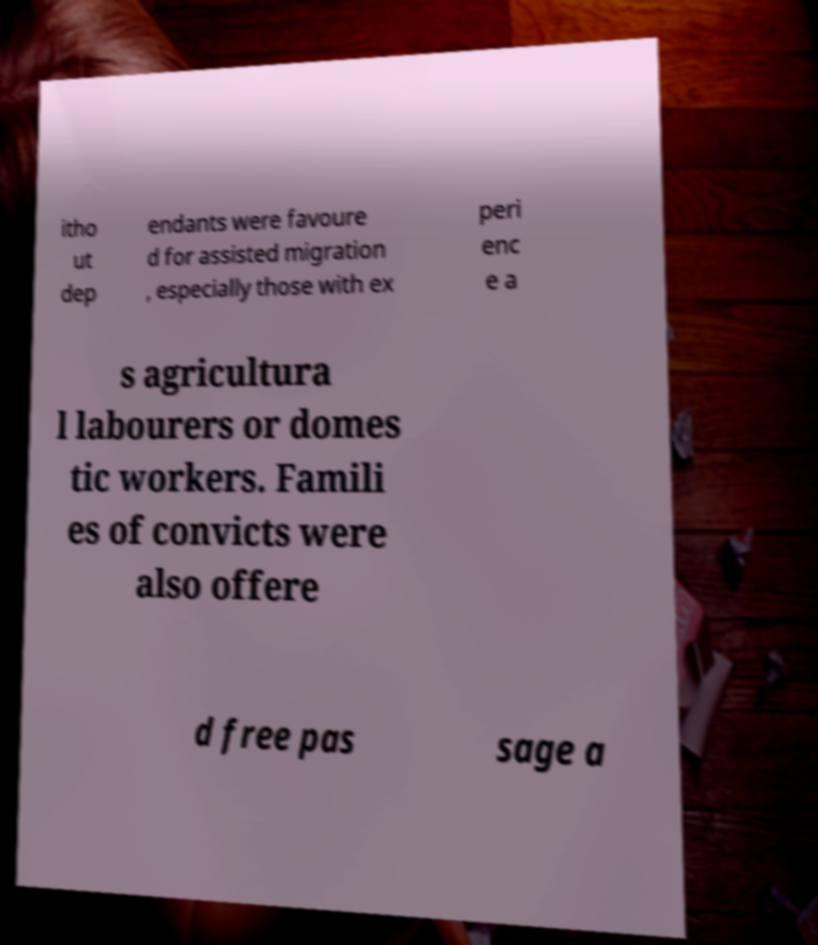What messages or text are displayed in this image? I need them in a readable, typed format. itho ut dep endants were favoure d for assisted migration , especially those with ex peri enc e a s agricultura l labourers or domes tic workers. Famili es of convicts were also offere d free pas sage a 